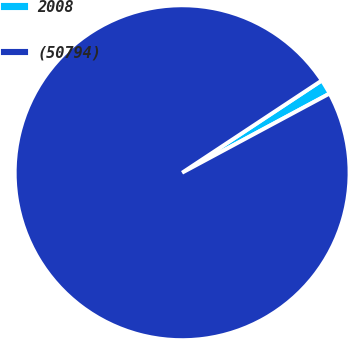<chart> <loc_0><loc_0><loc_500><loc_500><pie_chart><fcel>2008<fcel>(50794)<nl><fcel>1.45%<fcel>98.55%<nl></chart> 